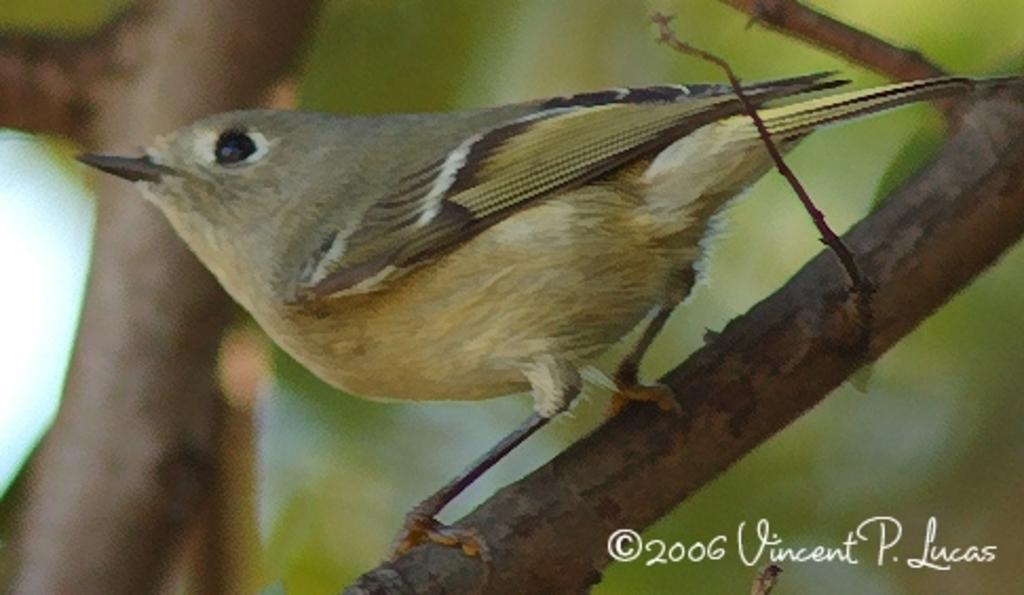In one or two sentences, can you explain what this image depicts? In the image there is a bird standing on a branch of a tree and the background is blurry. 